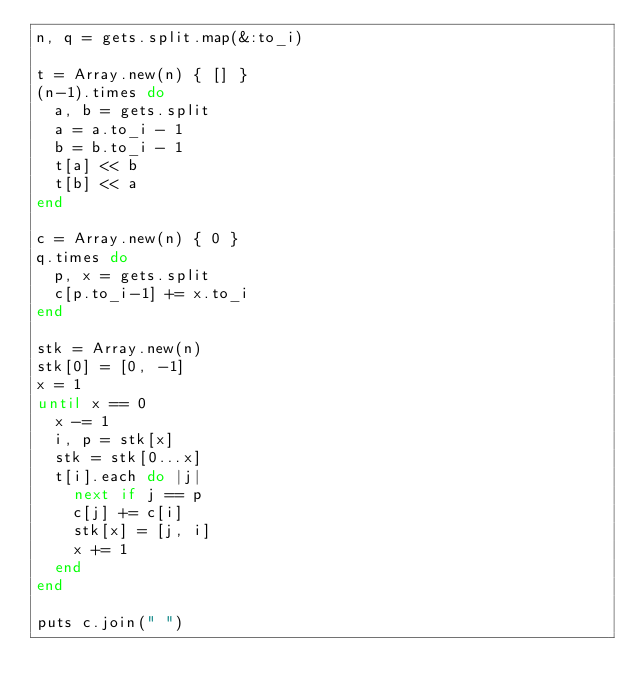Convert code to text. <code><loc_0><loc_0><loc_500><loc_500><_Ruby_>n, q = gets.split.map(&:to_i)

t = Array.new(n) { [] }
(n-1).times do
  a, b = gets.split
  a = a.to_i - 1
  b = b.to_i - 1
  t[a] << b
  t[b] << a
end

c = Array.new(n) { 0 }
q.times do
  p, x = gets.split
  c[p.to_i-1] += x.to_i
end

stk = Array.new(n)
stk[0] = [0, -1]
x = 1
until x == 0
  x -= 1
  i, p = stk[x]
  stk = stk[0...x]
  t[i].each do |j|
    next if j == p
    c[j] += c[i]
    stk[x] = [j, i]
    x += 1
  end
end

puts c.join(" ")</code> 